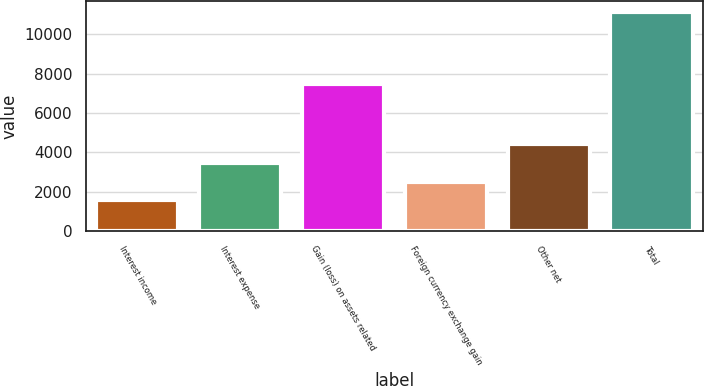Convert chart. <chart><loc_0><loc_0><loc_500><loc_500><bar_chart><fcel>Interest income<fcel>Interest expense<fcel>Gain (loss) on assets related<fcel>Foreign currency exchange gain<fcel>Other net<fcel>Total<nl><fcel>1567<fcel>3475.8<fcel>7498<fcel>2521.4<fcel>4430.2<fcel>11111<nl></chart> 